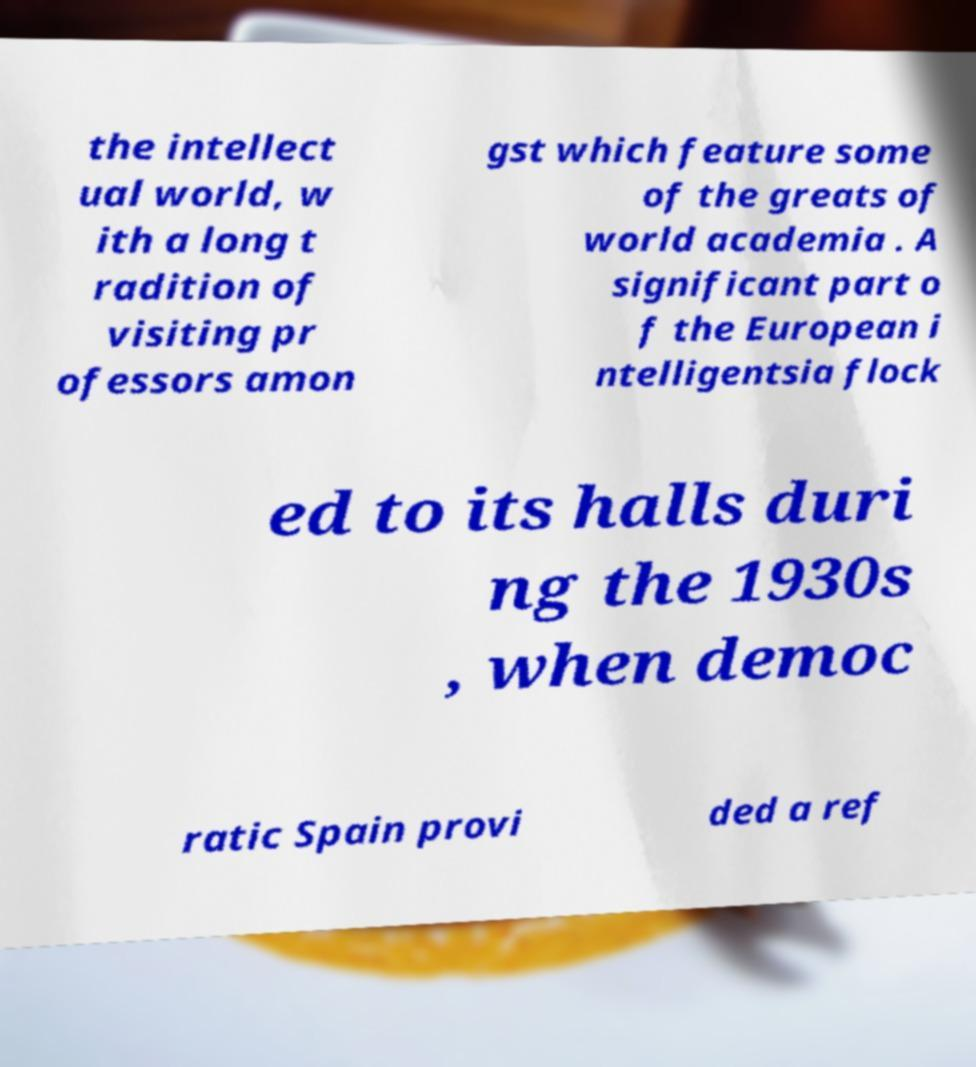What messages or text are displayed in this image? I need them in a readable, typed format. the intellect ual world, w ith a long t radition of visiting pr ofessors amon gst which feature some of the greats of world academia . A significant part o f the European i ntelligentsia flock ed to its halls duri ng the 1930s , when democ ratic Spain provi ded a ref 